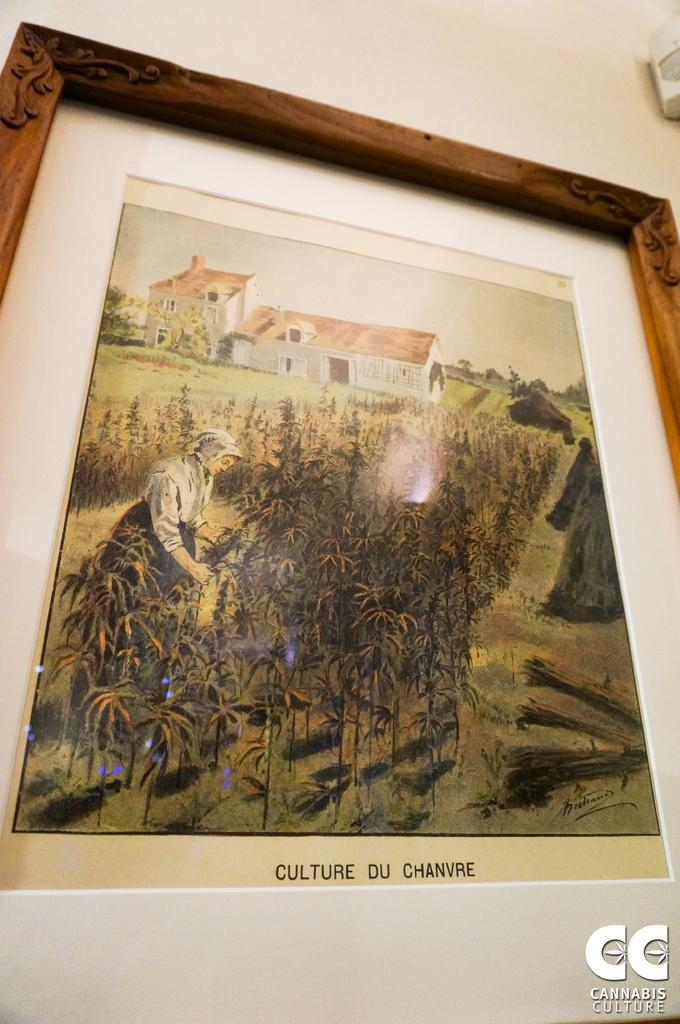Provide a one-sentence caption for the provided image. A painting, titled Culture du Chanvre, is in a frame and mounted on a wall. 